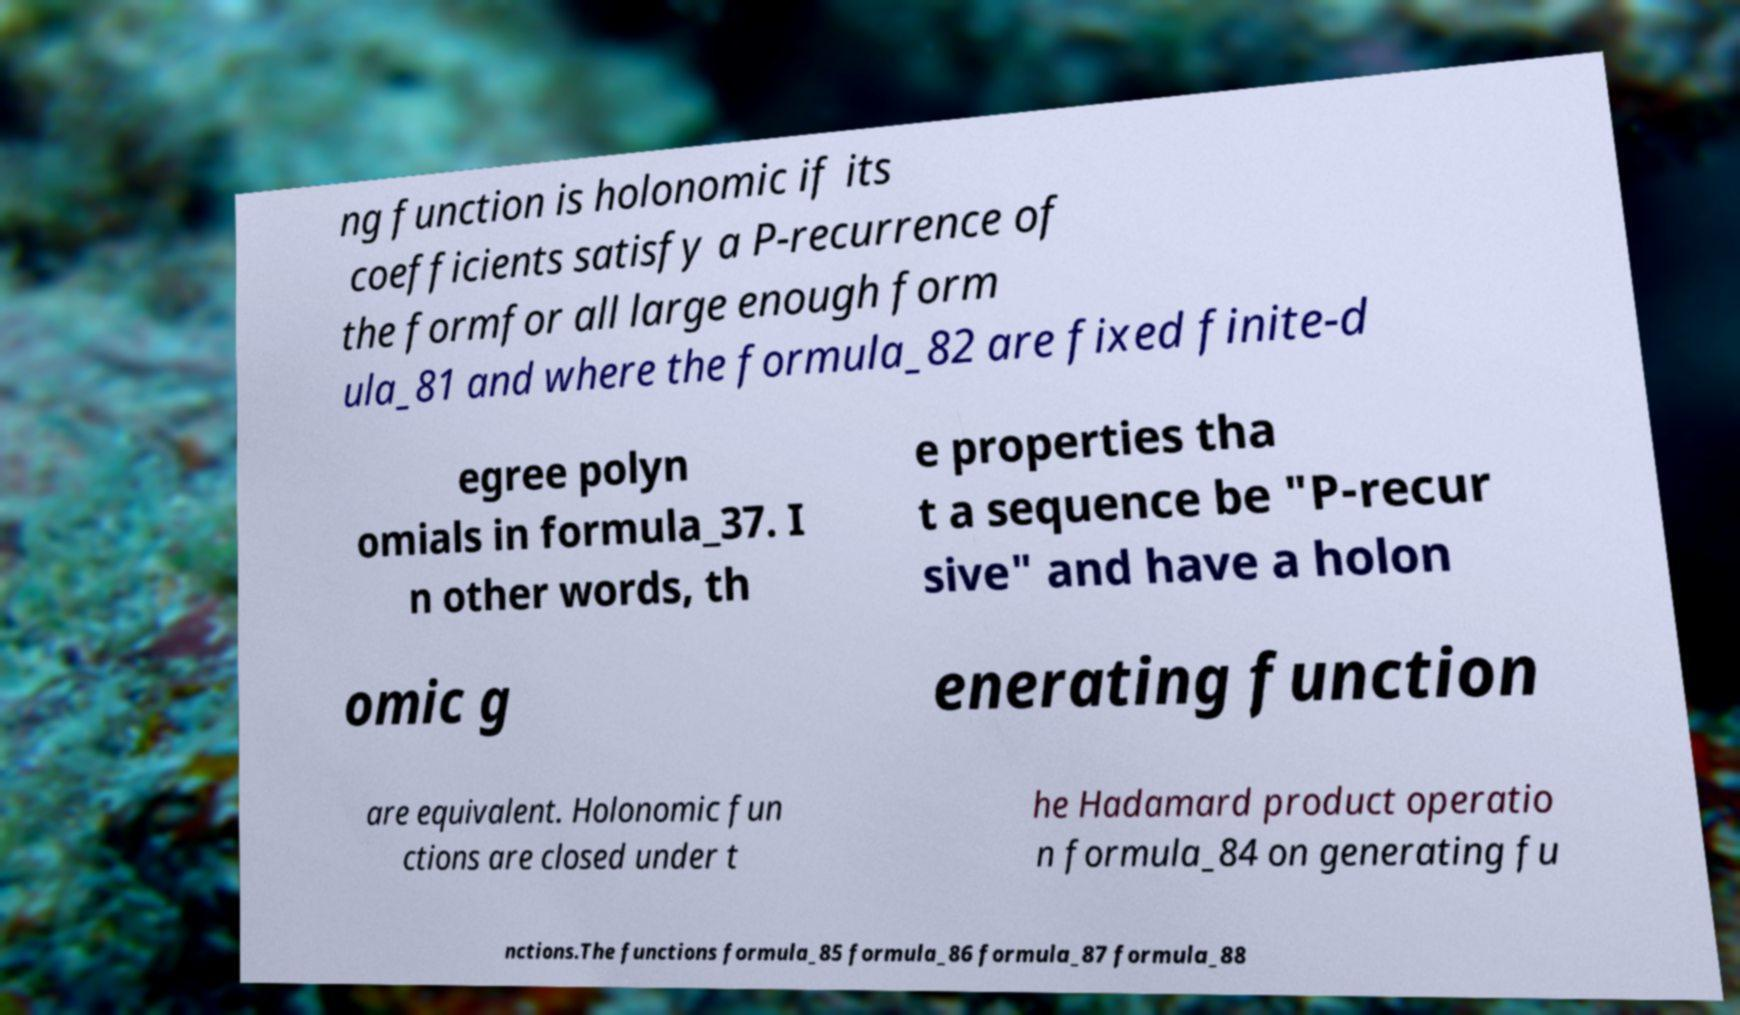What messages or text are displayed in this image? I need them in a readable, typed format. ng function is holonomic if its coefficients satisfy a P-recurrence of the formfor all large enough form ula_81 and where the formula_82 are fixed finite-d egree polyn omials in formula_37. I n other words, th e properties tha t a sequence be "P-recur sive" and have a holon omic g enerating function are equivalent. Holonomic fun ctions are closed under t he Hadamard product operatio n formula_84 on generating fu nctions.The functions formula_85 formula_86 formula_87 formula_88 